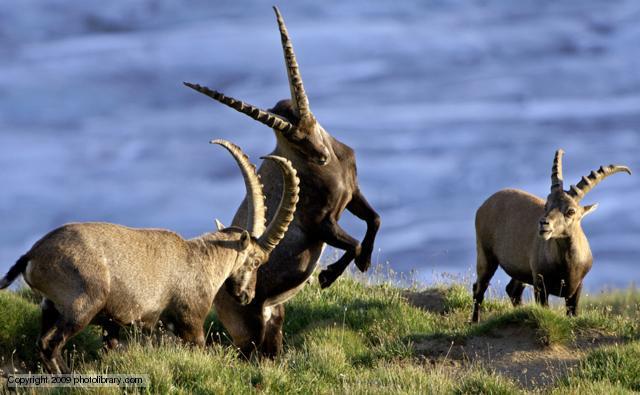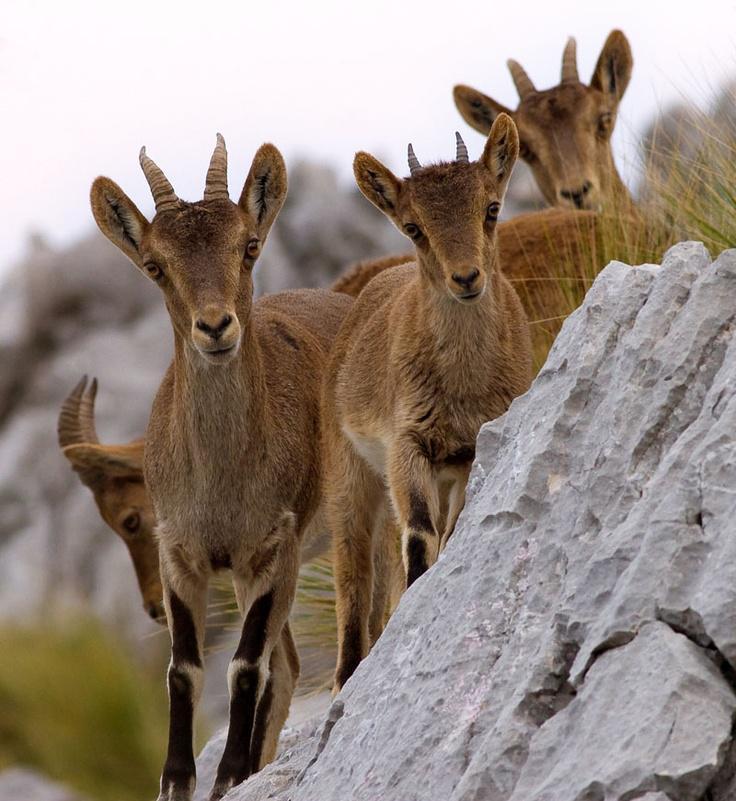The first image is the image on the left, the second image is the image on the right. Given the left and right images, does the statement "One image has more than one but less than three mountain goats." hold true? Answer yes or no. No. The first image is the image on the left, the second image is the image on the right. Evaluate the accuracy of this statement regarding the images: "One picture only has one goat in it.". Is it true? Answer yes or no. No. 